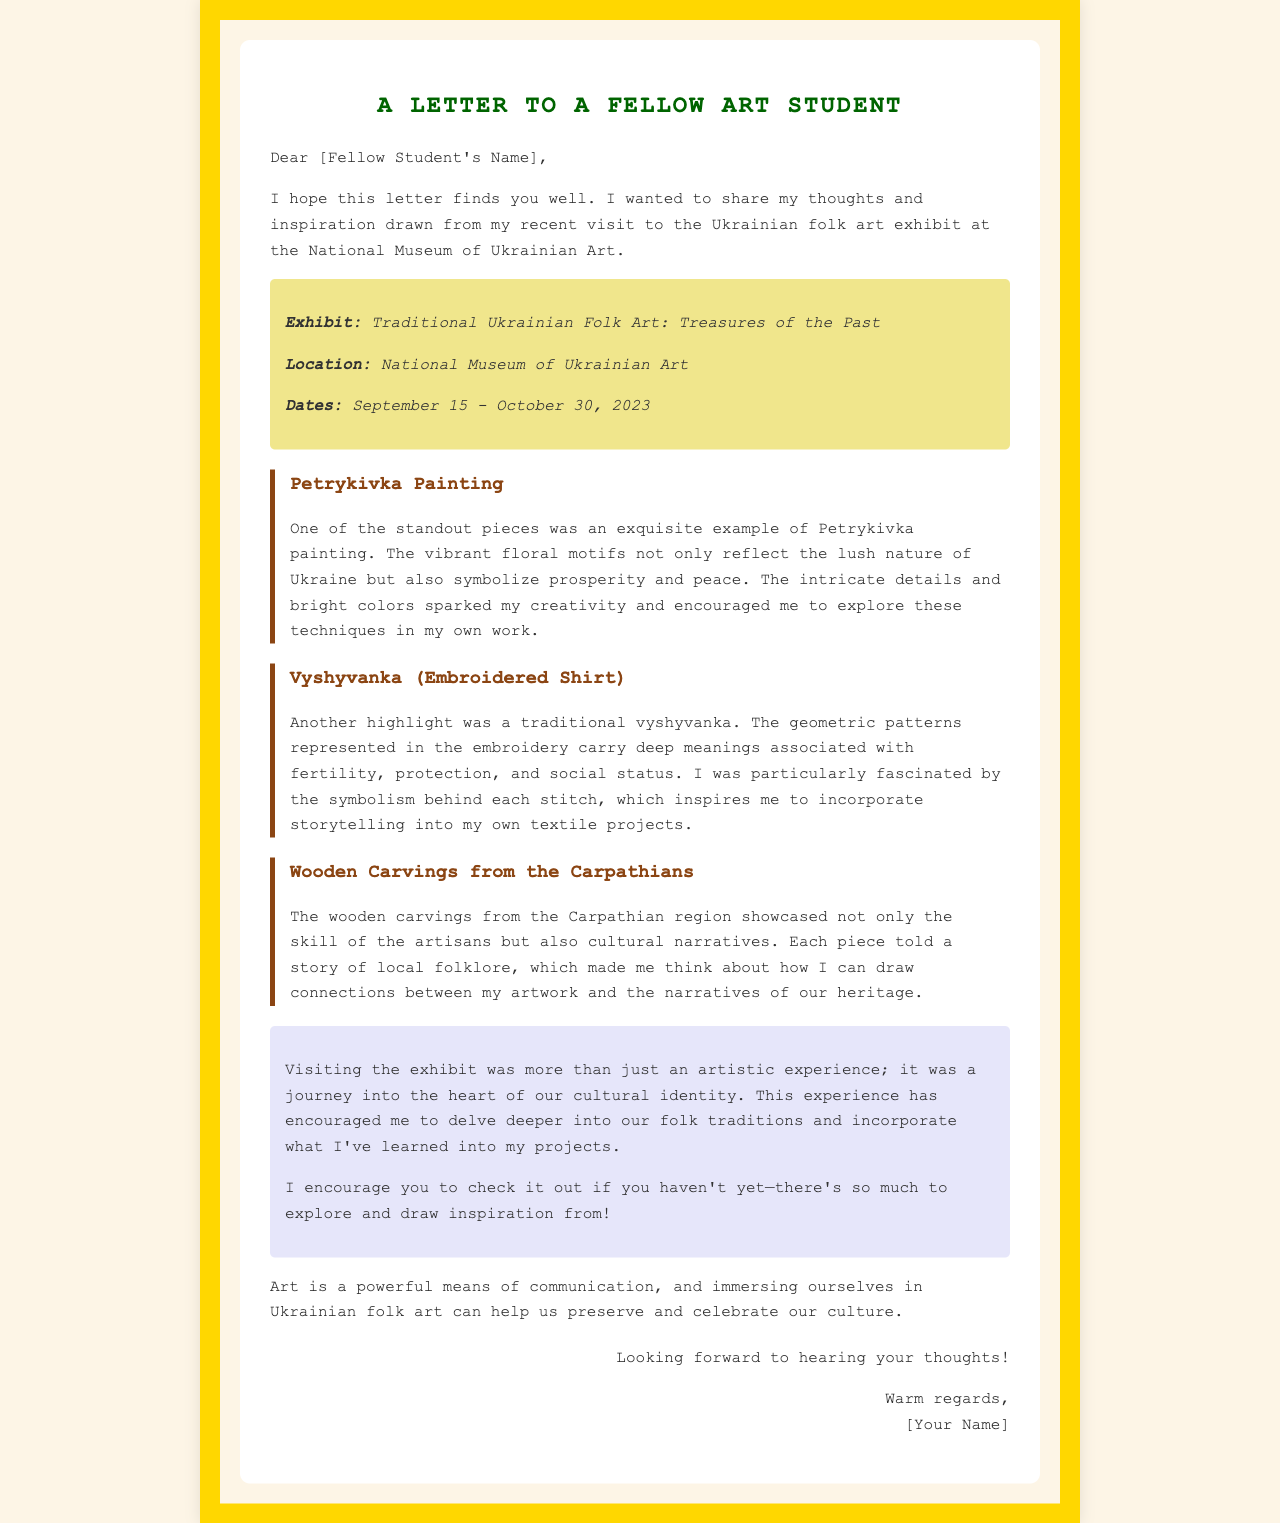what is the name of the exhibit? The name of the exhibit is mentioned in the document as "Traditional Ukrainian Folk Art: Treasures of the Past."
Answer: Traditional Ukrainian Folk Art: Treasures of the Past where was the exhibit held? The document specifies the location of the exhibit as the "National Museum of Ukrainian Art."
Answer: National Museum of Ukrainian Art when did the exhibit take place? The document states the dates for the exhibit from September 15 to October 30, 2023.
Answer: September 15 - October 30, 2023 what is one of the featured art forms mentioned in the letter? The letter references several art forms, including Petrykivka painting, vyshyvanka, and wooden carvings.
Answer: Petrykivka painting what does Petrykivka painting symbolize? According to the document, Petrykivka painting symbolizes prosperity and peace.
Answer: prosperity and peace how does the author describe the visit to the exhibit? The author reflects on the experience as a significant journey relating to cultural identity.
Answer: a journey into the heart of our cultural identity what cultural aspect is discussed in relation to the vyshyvanka? The document mentions that the geometric patterns in vyshyvanka embroidery carry meanings associated with fertility, protection, and social status.
Answer: fertility, protection, and social status what does the author encourage their fellow student to do? The author encourages their fellow student to visit the exhibit if they have not already.
Answer: check it out what effect did the exhibit have on the author’s creativity? The document states that the vivid details and colors sparked the author's creativity.
Answer: sparked my creativity 